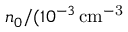<formula> <loc_0><loc_0><loc_500><loc_500>n _ { 0 } / ( 1 0 ^ { - 3 } \, c m ^ { - 3 }</formula> 